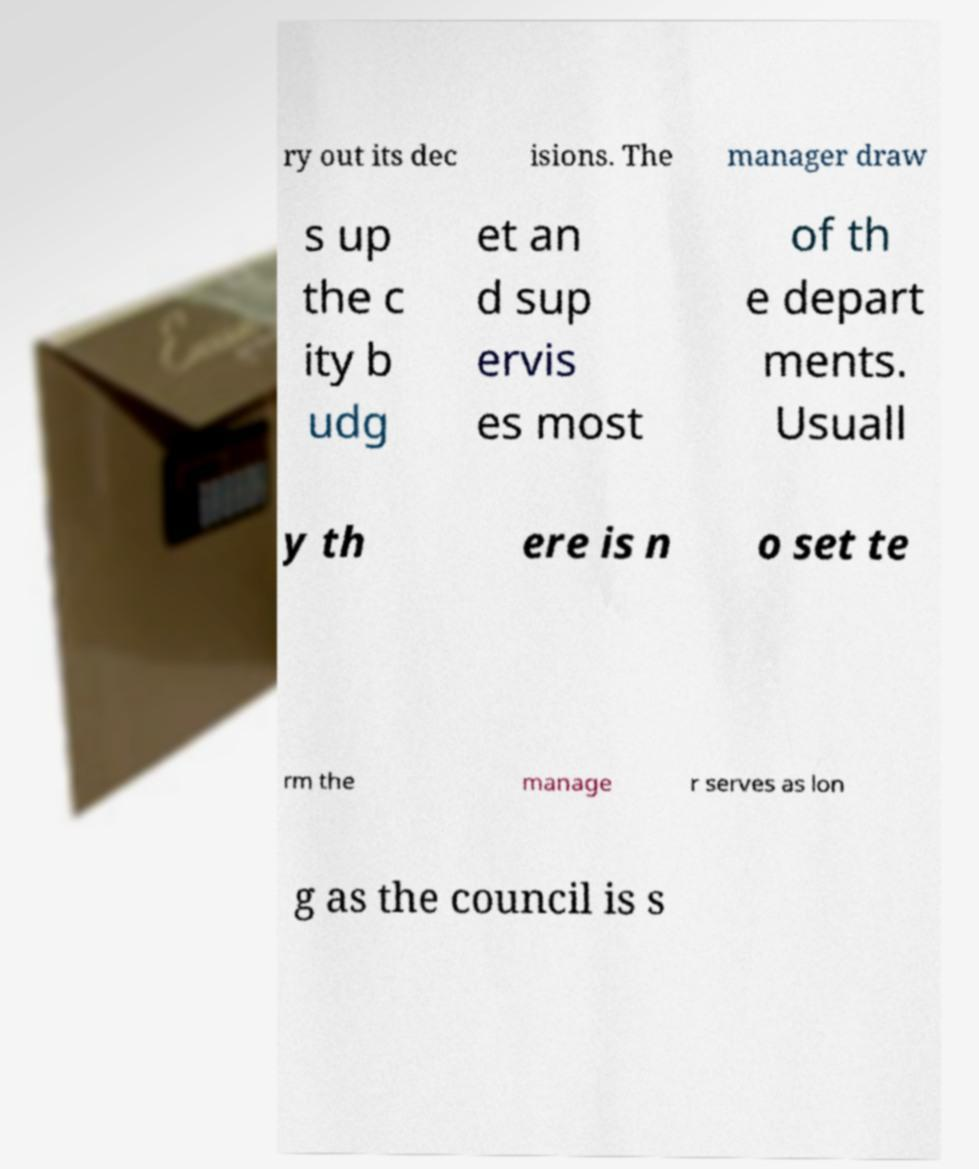Please read and relay the text visible in this image. What does it say? ry out its dec isions. The manager draw s up the c ity b udg et an d sup ervis es most of th e depart ments. Usuall y th ere is n o set te rm the manage r serves as lon g as the council is s 